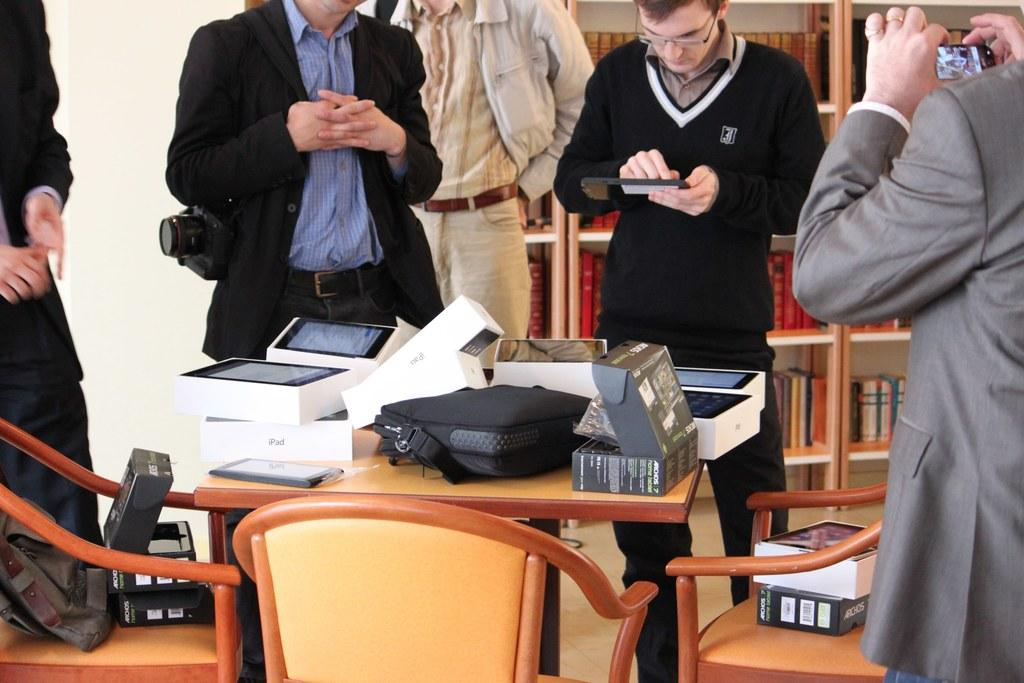How many people are in the image? There are several people in the image. What are the people doing in the image? The people are clicking images on an iPad. On what surface is the iPad placed? The iPad is on a brown table. What type of screw can be seen holding the can on the plough in the image? There is no screw, can, or plough present in the image. 